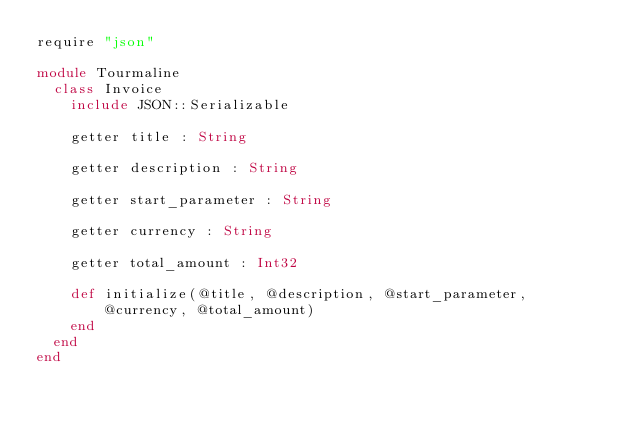<code> <loc_0><loc_0><loc_500><loc_500><_Crystal_>require "json"

module Tourmaline
  class Invoice
    include JSON::Serializable

    getter title : String

    getter description : String

    getter start_parameter : String

    getter currency : String

    getter total_amount : Int32

    def initialize(@title, @description, @start_parameter, @currency, @total_amount)
    end
  end
end
</code> 